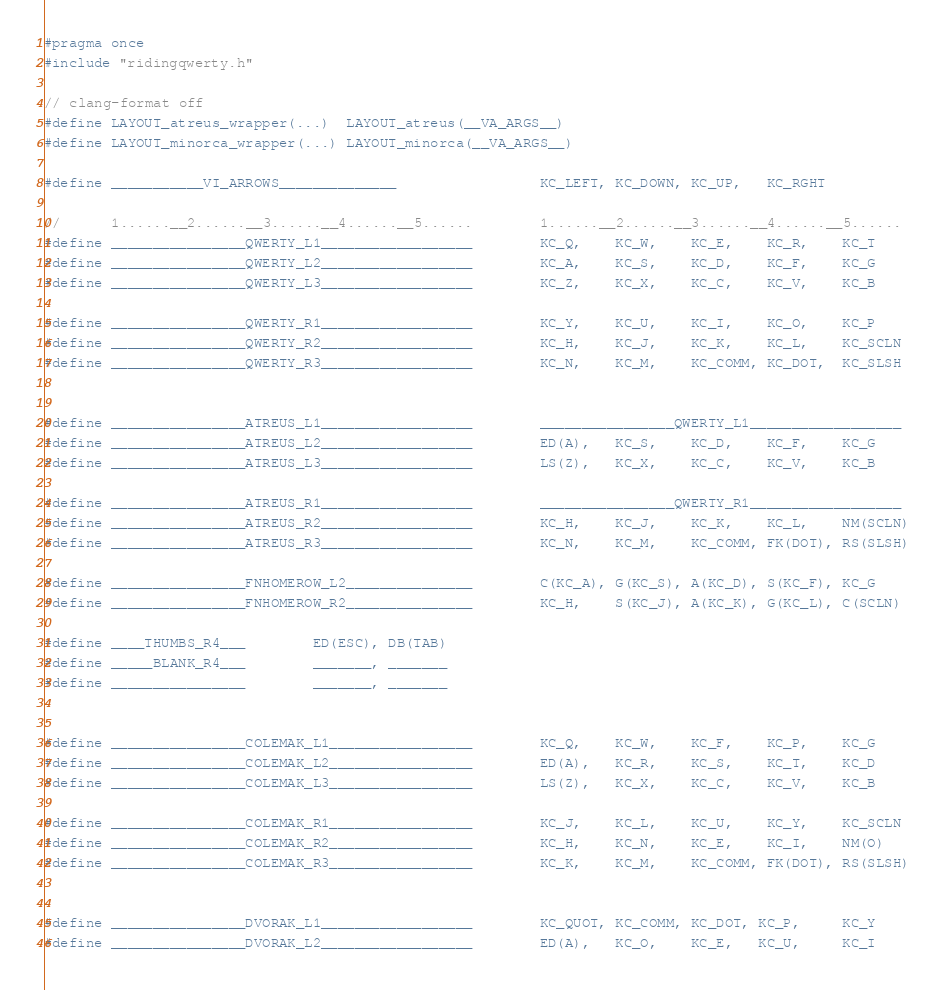<code> <loc_0><loc_0><loc_500><loc_500><_C_>#pragma once
#include "ridingqwerty.h"

// clang-format off
#define LAYOUT_atreus_wrapper(...)  LAYOUT_atreus(__VA_ARGS__)
#define LAYOUT_minorca_wrapper(...) LAYOUT_minorca(__VA_ARGS__)

#define ___________VI_ARROWS______________                 KC_LEFT, KC_DOWN, KC_UP,   KC_RGHT

//      1......__2......__3......__4......__5......        1......__2......__3......__4......__5......
#define ________________QWERTY_L1__________________        KC_Q,    KC_W,    KC_E,    KC_R,    KC_T
#define ________________QWERTY_L2__________________        KC_A,    KC_S,    KC_D,    KC_F,    KC_G
#define ________________QWERTY_L3__________________        KC_Z,    KC_X,    KC_C,    KC_V,    KC_B

#define ________________QWERTY_R1__________________        KC_Y,    KC_U,    KC_I,    KC_O,    KC_P
#define ________________QWERTY_R2__________________        KC_H,    KC_J,    KC_K,    KC_L,    KC_SCLN
#define ________________QWERTY_R3__________________        KC_N,    KC_M,    KC_COMM, KC_DOT,  KC_SLSH


#define ________________ATREUS_L1__________________        ________________QWERTY_L1__________________
#define ________________ATREUS_L2__________________        ED(A),   KC_S,    KC_D,    KC_F,    KC_G
#define ________________ATREUS_L3__________________        LS(Z),   KC_X,    KC_C,    KC_V,    KC_B

#define ________________ATREUS_R1__________________        ________________QWERTY_R1__________________
#define ________________ATREUS_R2__________________        KC_H,    KC_J,    KC_K,    KC_L,    NM(SCLN)
#define ________________ATREUS_R3__________________        KC_N,    KC_M,    KC_COMM, FK(DOT), RS(SLSH)

#define ________________FNHOMEROW_L2_______________        C(KC_A), G(KC_S), A(KC_D), S(KC_F), KC_G
#define ________________FNHOMEROW_R2_______________        KC_H,    S(KC_J), A(KC_K), G(KC_L), C(SCLN)

#define ____THUMBS_R4___        ED(ESC), DB(TAB)
#define _____BLANK_R4___        _______, _______
#define ________________        _______, _______


#define ________________COLEMAK_L1_________________        KC_Q,    KC_W,    KC_F,    KC_P,    KC_G
#define ________________COLEMAK_L2_________________        ED(A),   KC_R,    KC_S,    KC_T,    KC_D
#define ________________COLEMAK_L3_________________        LS(Z),   KC_X,    KC_C,    KC_V,    KC_B

#define ________________COLEMAK_R1_________________        KC_J,    KC_L,    KC_U,    KC_Y,    KC_SCLN
#define ________________COLEMAK_R2_________________        KC_H,    KC_N,    KC_E,    KC_I,    NM(O)
#define ________________COLEMAK_R3_________________        KC_K,    KC_M,    KC_COMM, FK(DOT), RS(SLSH)


#define ________________DVORAK_L1__________________        KC_QUOT, KC_COMM, KC_DOT, KC_P,     KC_Y
#define ________________DVORAK_L2__________________        ED(A),   KC_O,    KC_E,   KC_U,     KC_I</code> 